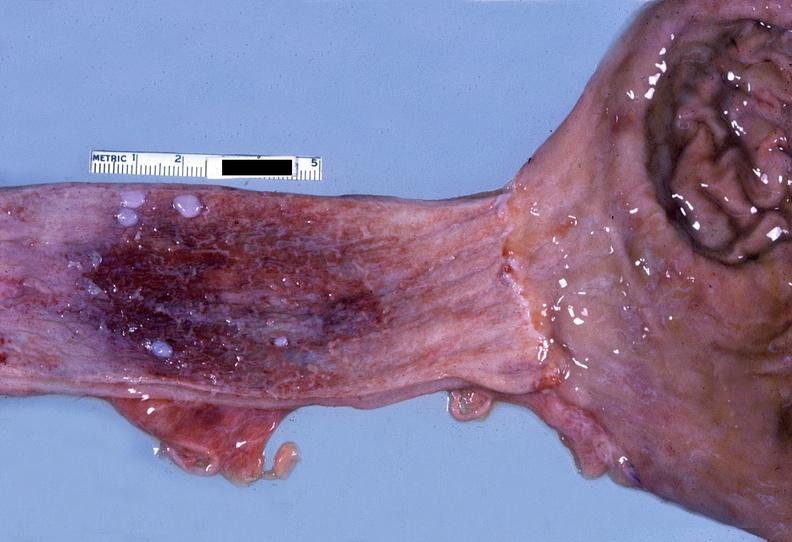does hemorrhagic corpus luteum show esophagus, herpes esophagitis?
Answer the question using a single word or phrase. No 